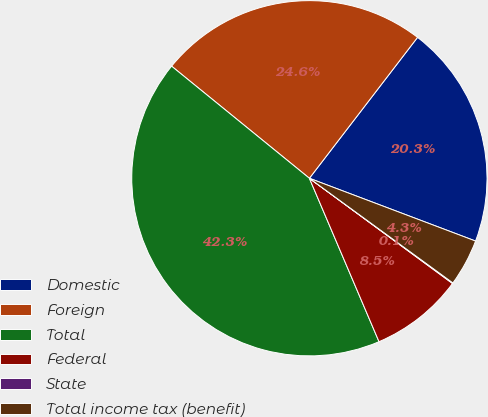Convert chart. <chart><loc_0><loc_0><loc_500><loc_500><pie_chart><fcel>Domestic<fcel>Foreign<fcel>Total<fcel>Federal<fcel>State<fcel>Total income tax (benefit)<nl><fcel>20.33%<fcel>24.55%<fcel>42.28%<fcel>8.5%<fcel>0.06%<fcel>4.28%<nl></chart> 